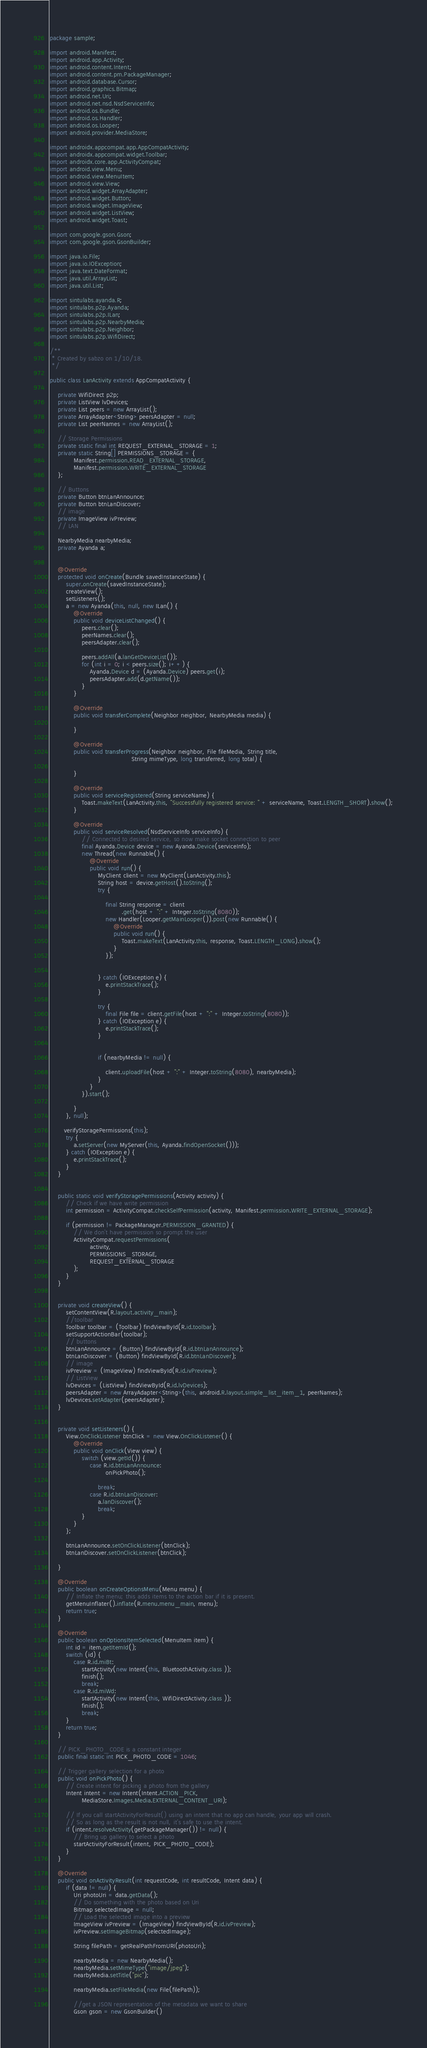Convert code to text. <code><loc_0><loc_0><loc_500><loc_500><_Java_>package sample;

import android.Manifest;
import android.app.Activity;
import android.content.Intent;
import android.content.pm.PackageManager;
import android.database.Cursor;
import android.graphics.Bitmap;
import android.net.Uri;
import android.net.nsd.NsdServiceInfo;
import android.os.Bundle;
import android.os.Handler;
import android.os.Looper;
import android.provider.MediaStore;

import androidx.appcompat.app.AppCompatActivity;
import androidx.appcompat.widget.Toolbar;
import androidx.core.app.ActivityCompat;
import android.view.Menu;
import android.view.MenuItem;
import android.view.View;
import android.widget.ArrayAdapter;
import android.widget.Button;
import android.widget.ImageView;
import android.widget.ListView;
import android.widget.Toast;

import com.google.gson.Gson;
import com.google.gson.GsonBuilder;

import java.io.File;
import java.io.IOException;
import java.text.DateFormat;
import java.util.ArrayList;
import java.util.List;

import sintulabs.ayanda.R;
import sintulabs.p2p.Ayanda;
import sintulabs.p2p.ILan;
import sintulabs.p2p.NearbyMedia;
import sintulabs.p2p.Neighbor;
import sintulabs.p2p.WifiDirect;

/**
 * Created by sabzo on 1/10/18.
 */

public class LanActivity extends AppCompatActivity {

    private WifiDirect p2p;
    private ListView lvDevices;
    private List peers = new ArrayList();
    private ArrayAdapter<String> peersAdapter = null;
    private List peerNames = new ArrayList();

    // Storage Permissions
    private static final int REQUEST_EXTERNAL_STORAGE = 1;
    private static String[] PERMISSIONS_STORAGE = {
            Manifest.permission.READ_EXTERNAL_STORAGE,
            Manifest.permission.WRITE_EXTERNAL_STORAGE
    };

    // Buttons
    private Button btnLanAnnounce;
    private Button btnLanDiscover;
    // image
    private ImageView ivPreview;
    // LAN

    NearbyMedia nearbyMedia;
    private Ayanda a;


    @Override
    protected void onCreate(Bundle savedInstanceState) {
        super.onCreate(savedInstanceState);
        createView();
        setListeners();
        a = new Ayanda(this, null, new ILan() {
            @Override
            public void deviceListChanged() {
                peers.clear();
                peerNames.clear();
                peersAdapter.clear();

                peers.addAll(a.lanGetDeviceList());
                for (int i = 0; i < peers.size(); i++) {
                    Ayanda.Device d = (Ayanda.Device) peers.get(i);
                    peersAdapter.add(d.getName());
                }
            }

            @Override
            public void transferComplete(Neighbor neighbor, NearbyMedia media) {

            }

            @Override
            public void transferProgress(Neighbor neighbor, File fileMedia, String title,
                                         String mimeType, long transferred, long total) {

            }

            @Override
            public void serviceRegistered(String serviceName) {
                Toast.makeText(LanActivity.this, "Successfully registered service: " + serviceName, Toast.LENGTH_SHORT).show();
            }

            @Override
            public void serviceResolved(NsdServiceInfo serviceInfo) {
                // Connected to desired service, so now make socket connection to peer
                final Ayanda.Device device = new Ayanda.Device(serviceInfo);
                new Thread(new Runnable() {
                    @Override
                    public void run() {
                        MyClient client = new MyClient(LanActivity.this);
                        String host = device.getHost().toString();
                        try {

                            final String response = client
                                    .get(host + ":" + Integer.toString(8080));
                            new Handler(Looper.getMainLooper()).post(new Runnable() {
                                @Override
                                public void run() {
                                    Toast.makeText(LanActivity.this, response, Toast.LENGTH_LONG).show();
                                }
                            });


                        } catch (IOException e) {
                            e.printStackTrace();
                        }

                        try {
                            final File file = client.getFile(host + ":" + Integer.toString(8080));
                        } catch (IOException e) {
                            e.printStackTrace();
                        }


                        if (nearbyMedia != null) {

                            client.uploadFile(host + ":" + Integer.toString(8080), nearbyMedia);
                        }
                    }
                }).start();

            }
        }, null);

       verifyStoragePermissions(this);
        try {
            a.setServer(new MyServer(this, Ayanda.findOpenSocket()));
        } catch (IOException e) {
            e.printStackTrace();
        }
    }


    public static void verifyStoragePermissions(Activity activity) {
        // Check if we have write permission
        int permission = ActivityCompat.checkSelfPermission(activity, Manifest.permission.WRITE_EXTERNAL_STORAGE);

        if (permission != PackageManager.PERMISSION_GRANTED) {
            // We don't have permission so prompt the user
            ActivityCompat.requestPermissions(
                    activity,
                    PERMISSIONS_STORAGE,
                    REQUEST_EXTERNAL_STORAGE
            );
        }
    }


    private void createView() {
        setContentView(R.layout.activity_main);
        //toolbar
        Toolbar toolbar = (Toolbar) findViewById(R.id.toolbar);
        setSupportActionBar(toolbar);
        // buttons
        btnLanAnnounce = (Button) findViewById(R.id.btnLanAnnounce);
        btnLanDiscover = (Button) findViewById(R.id.btnLanDiscover);
        // image
        ivPreview = (ImageView) findViewById(R.id.ivPreview);
        // ListView
        lvDevices = (ListView) findViewById(R.id.lvDevices);
        peersAdapter = new ArrayAdapter<String>(this, android.R.layout.simple_list_item_1, peerNames);
        lvDevices.setAdapter(peersAdapter);
    }


    private void setListeners() {
        View.OnClickListener btnClick = new View.OnClickListener() {
            @Override
            public void onClick(View view) {
                switch (view.getId()) {
                    case R.id.btnLanAnnounce:
                            onPickPhoto();

                        break;
                    case R.id.btnLanDiscover:
                        a.lanDiscover();
                        break;
                }
            }
        };

        btnLanAnnounce.setOnClickListener(btnClick);
        btnLanDiscover.setOnClickListener(btnClick);

    }

    @Override
    public boolean onCreateOptionsMenu(Menu menu) {
        // Inflate the menu; this adds items to the action bar if it is present.
        getMenuInflater().inflate(R.menu.menu_main, menu);
        return true;
    }

    @Override
    public boolean onOptionsItemSelected(MenuItem item) {
        int id = item.getItemId();
        switch (id) {
            case R.id.miBt:
                startActivity(new Intent(this, BluetoothActivity.class ));
                finish();
                break;
            case R.id.miWd:
                startActivity(new Intent(this, WifiDirectActivity.class ));
                finish();
                break;
        }
        return true;
    }

    // PICK_PHOTO_CODE is a constant integer
    public final static int PICK_PHOTO_CODE = 1046;

    // Trigger gallery selection for a photo
    public void onPickPhoto() {
        // Create intent for picking a photo from the gallery
        Intent intent = new Intent(Intent.ACTION_PICK,
                MediaStore.Images.Media.EXTERNAL_CONTENT_URI);

        // If you call startActivityForResult() using an intent that no app can handle, your app will crash.
        // So as long as the result is not null, it's safe to use the intent.
        if (intent.resolveActivity(getPackageManager()) != null) {
            // Bring up gallery to select a photo
            startActivityForResult(intent, PICK_PHOTO_CODE);
        }
    }

    @Override
    public void onActivityResult(int requestCode, int resultCode, Intent data) {
        if (data != null) {
            Uri photoUri = data.getData();
            // Do something with the photo based on Uri
            Bitmap selectedImage = null;
            // Load the selected image into a preview
            ImageView ivPreview = (ImageView) findViewById(R.id.ivPreview);
            ivPreview.setImageBitmap(selectedImage);

            String filePath = getRealPathFromURI(photoUri);

            nearbyMedia = new NearbyMedia();
            nearbyMedia.setMimeType("image/jpeg");
            nearbyMedia.setTitle("pic");

            nearbyMedia.setFileMedia(new File(filePath));

            //get a JSON representation of the metadata we want to share
            Gson gson = new GsonBuilder()</code> 